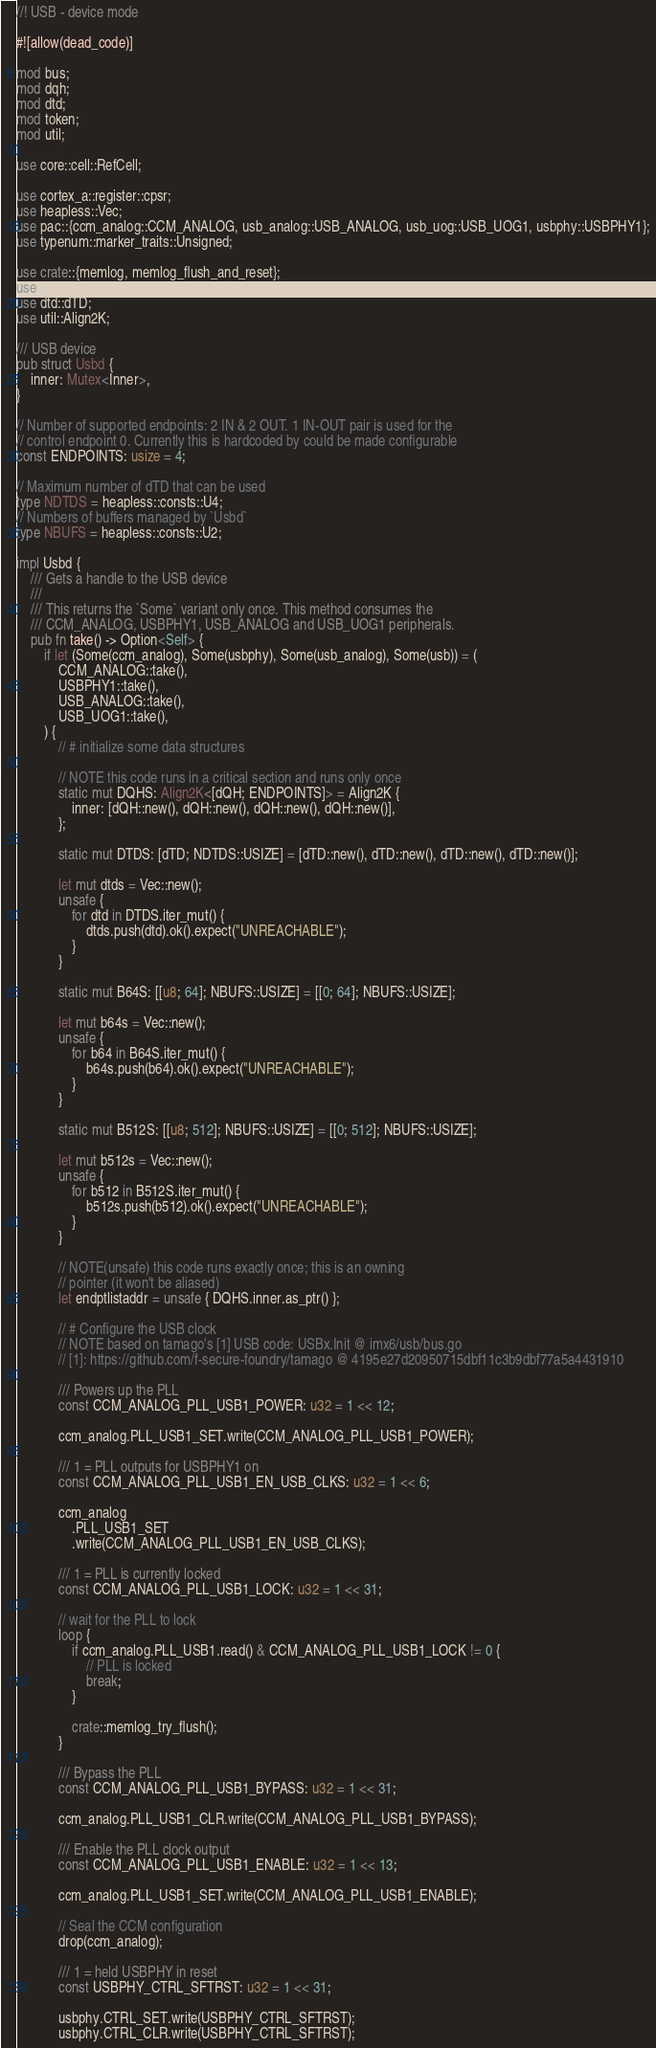Convert code to text. <code><loc_0><loc_0><loc_500><loc_500><_Rust_>//! USB - device mode

#![allow(dead_code)]

mod bus;
mod dqh;
mod dtd;
mod token;
mod util;

use core::cell::RefCell;

use cortex_a::register::cpsr;
use heapless::Vec;
use pac::{ccm_analog::CCM_ANALOG, usb_analog::USB_ANALOG, usb_uog::USB_UOG1, usbphy::USBPHY1};
use typenum::marker_traits::Unsigned;

use crate::{memlog, memlog_flush_and_reset};
use dqh::dQH;
use dtd::dTD;
use util::Align2K;

/// USB device
pub struct Usbd {
    inner: Mutex<Inner>,
}

// Number of supported endpoints: 2 IN & 2 OUT. 1 IN-OUT pair is used for the
// control endpoint 0. Currently this is hardcoded by could be made configurable
const ENDPOINTS: usize = 4;

// Maximum number of dTD that can be used
type NDTDS = heapless::consts::U4;
// Numbers of buffers managed by `Usbd`
type NBUFS = heapless::consts::U2;

impl Usbd {
    /// Gets a handle to the USB device
    ///
    /// This returns the `Some` variant only once. This method consumes the
    /// CCM_ANALOG, USBPHY1, USB_ANALOG and USB_UOG1 peripherals.
    pub fn take() -> Option<Self> {
        if let (Some(ccm_analog), Some(usbphy), Some(usb_analog), Some(usb)) = (
            CCM_ANALOG::take(),
            USBPHY1::take(),
            USB_ANALOG::take(),
            USB_UOG1::take(),
        ) {
            // # initialize some data structures

            // NOTE this code runs in a critical section and runs only once
            static mut DQHS: Align2K<[dQH; ENDPOINTS]> = Align2K {
                inner: [dQH::new(), dQH::new(), dQH::new(), dQH::new()],
            };

            static mut DTDS: [dTD; NDTDS::USIZE] = [dTD::new(), dTD::new(), dTD::new(), dTD::new()];

            let mut dtds = Vec::new();
            unsafe {
                for dtd in DTDS.iter_mut() {
                    dtds.push(dtd).ok().expect("UNREACHABLE");
                }
            }

            static mut B64S: [[u8; 64]; NBUFS::USIZE] = [[0; 64]; NBUFS::USIZE];

            let mut b64s = Vec::new();
            unsafe {
                for b64 in B64S.iter_mut() {
                    b64s.push(b64).ok().expect("UNREACHABLE");
                }
            }

            static mut B512S: [[u8; 512]; NBUFS::USIZE] = [[0; 512]; NBUFS::USIZE];

            let mut b512s = Vec::new();
            unsafe {
                for b512 in B512S.iter_mut() {
                    b512s.push(b512).ok().expect("UNREACHABLE");
                }
            }

            // NOTE(unsafe) this code runs exactly once; this is an owning
            // pointer (it won't be aliased)
            let endptlistaddr = unsafe { DQHS.inner.as_ptr() };

            // # Configure the USB clock
            // NOTE based on tamago's [1] USB code: USBx.Init @ imx6/usb/bus.go
            // [1]: https://github.com/f-secure-foundry/tamago @ 4195e27d20950715dbf11c3b9dbf77a5a4431910

            /// Powers up the PLL
            const CCM_ANALOG_PLL_USB1_POWER: u32 = 1 << 12;

            ccm_analog.PLL_USB1_SET.write(CCM_ANALOG_PLL_USB1_POWER);

            /// 1 = PLL outputs for USBPHY1 on
            const CCM_ANALOG_PLL_USB1_EN_USB_CLKS: u32 = 1 << 6;

            ccm_analog
                .PLL_USB1_SET
                .write(CCM_ANALOG_PLL_USB1_EN_USB_CLKS);

            /// 1 = PLL is currently locked
            const CCM_ANALOG_PLL_USB1_LOCK: u32 = 1 << 31;

            // wait for the PLL to lock
            loop {
                if ccm_analog.PLL_USB1.read() & CCM_ANALOG_PLL_USB1_LOCK != 0 {
                    // PLL is locked
                    break;
                }

                crate::memlog_try_flush();
            }

            /// Bypass the PLL
            const CCM_ANALOG_PLL_USB1_BYPASS: u32 = 1 << 31;

            ccm_analog.PLL_USB1_CLR.write(CCM_ANALOG_PLL_USB1_BYPASS);

            /// Enable the PLL clock output
            const CCM_ANALOG_PLL_USB1_ENABLE: u32 = 1 << 13;

            ccm_analog.PLL_USB1_SET.write(CCM_ANALOG_PLL_USB1_ENABLE);

            // Seal the CCM configuration
            drop(ccm_analog);

            /// 1 = held USBPHY in reset
            const USBPHY_CTRL_SFTRST: u32 = 1 << 31;

            usbphy.CTRL_SET.write(USBPHY_CTRL_SFTRST);
            usbphy.CTRL_CLR.write(USBPHY_CTRL_SFTRST);
</code> 